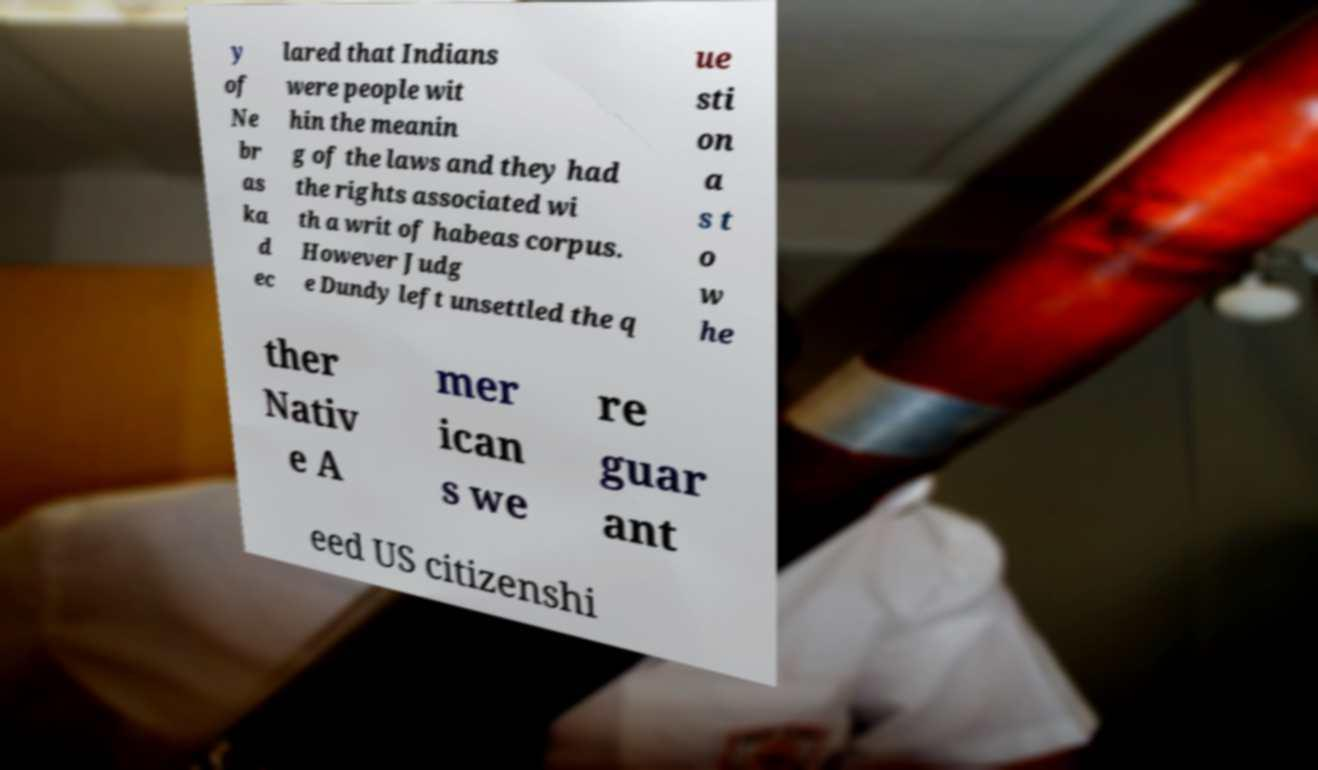Could you assist in decoding the text presented in this image and type it out clearly? y of Ne br as ka d ec lared that Indians were people wit hin the meanin g of the laws and they had the rights associated wi th a writ of habeas corpus. However Judg e Dundy left unsettled the q ue sti on a s t o w he ther Nativ e A mer ican s we re guar ant eed US citizenshi 